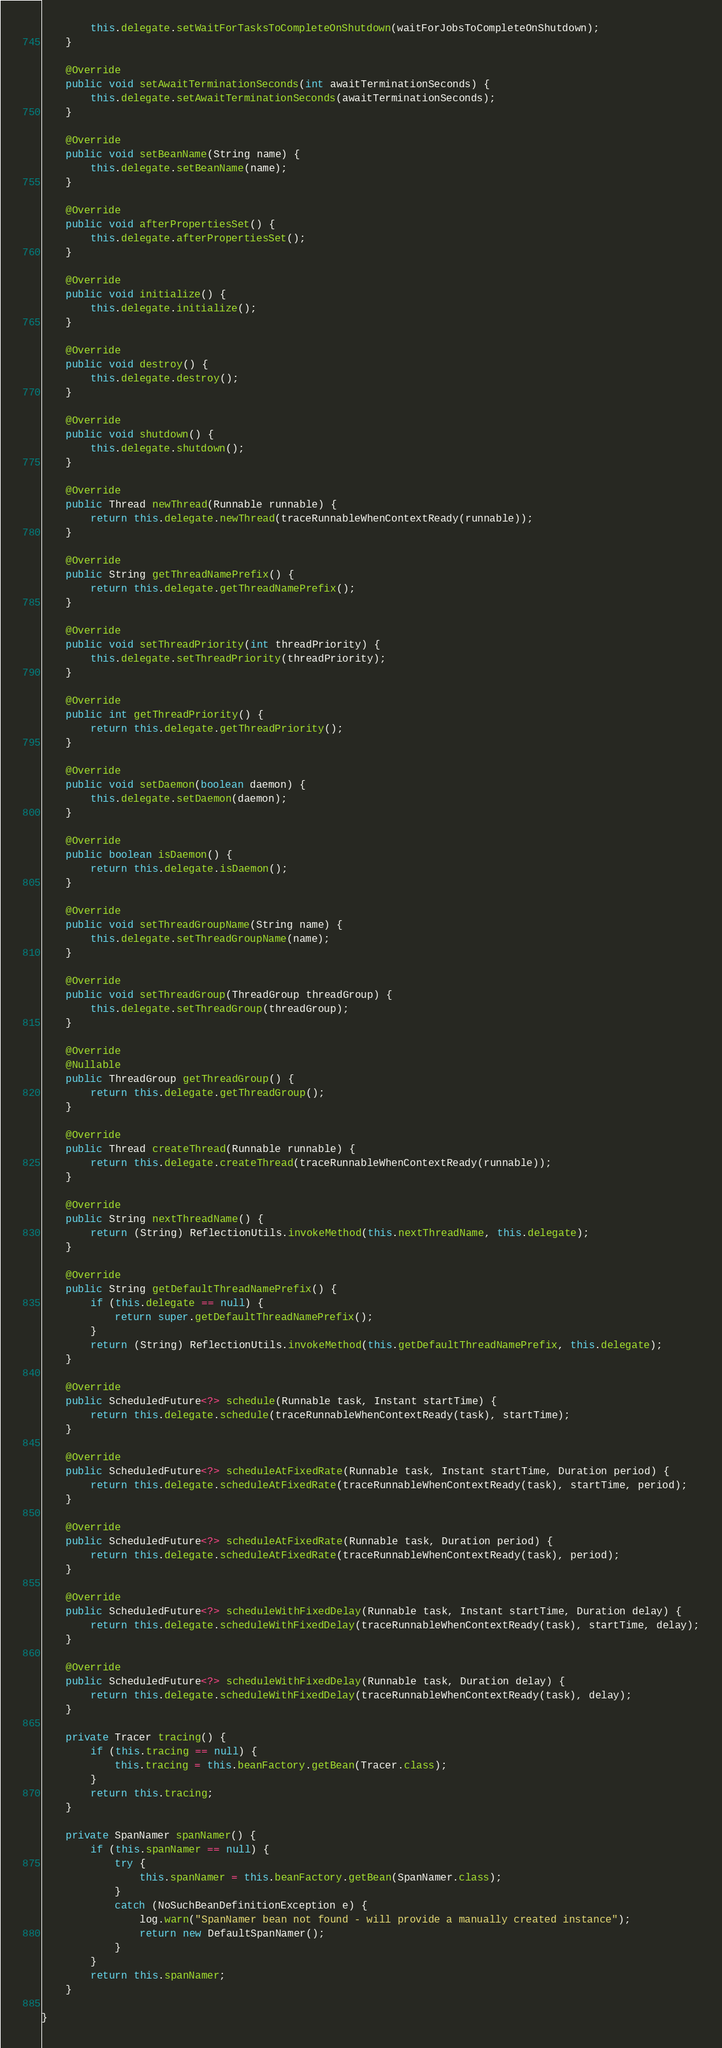Convert code to text. <code><loc_0><loc_0><loc_500><loc_500><_Java_>		this.delegate.setWaitForTasksToCompleteOnShutdown(waitForJobsToCompleteOnShutdown);
	}

	@Override
	public void setAwaitTerminationSeconds(int awaitTerminationSeconds) {
		this.delegate.setAwaitTerminationSeconds(awaitTerminationSeconds);
	}

	@Override
	public void setBeanName(String name) {
		this.delegate.setBeanName(name);
	}

	@Override
	public void afterPropertiesSet() {
		this.delegate.afterPropertiesSet();
	}

	@Override
	public void initialize() {
		this.delegate.initialize();
	}

	@Override
	public void destroy() {
		this.delegate.destroy();
	}

	@Override
	public void shutdown() {
		this.delegate.shutdown();
	}

	@Override
	public Thread newThread(Runnable runnable) {
		return this.delegate.newThread(traceRunnableWhenContextReady(runnable));
	}

	@Override
	public String getThreadNamePrefix() {
		return this.delegate.getThreadNamePrefix();
	}

	@Override
	public void setThreadPriority(int threadPriority) {
		this.delegate.setThreadPriority(threadPriority);
	}

	@Override
	public int getThreadPriority() {
		return this.delegate.getThreadPriority();
	}

	@Override
	public void setDaemon(boolean daemon) {
		this.delegate.setDaemon(daemon);
	}

	@Override
	public boolean isDaemon() {
		return this.delegate.isDaemon();
	}

	@Override
	public void setThreadGroupName(String name) {
		this.delegate.setThreadGroupName(name);
	}

	@Override
	public void setThreadGroup(ThreadGroup threadGroup) {
		this.delegate.setThreadGroup(threadGroup);
	}

	@Override
	@Nullable
	public ThreadGroup getThreadGroup() {
		return this.delegate.getThreadGroup();
	}

	@Override
	public Thread createThread(Runnable runnable) {
		return this.delegate.createThread(traceRunnableWhenContextReady(runnable));
	}

	@Override
	public String nextThreadName() {
		return (String) ReflectionUtils.invokeMethod(this.nextThreadName, this.delegate);
	}

	@Override
	public String getDefaultThreadNamePrefix() {
		if (this.delegate == null) {
			return super.getDefaultThreadNamePrefix();
		}
		return (String) ReflectionUtils.invokeMethod(this.getDefaultThreadNamePrefix, this.delegate);
	}

	@Override
	public ScheduledFuture<?> schedule(Runnable task, Instant startTime) {
		return this.delegate.schedule(traceRunnableWhenContextReady(task), startTime);
	}

	@Override
	public ScheduledFuture<?> scheduleAtFixedRate(Runnable task, Instant startTime, Duration period) {
		return this.delegate.scheduleAtFixedRate(traceRunnableWhenContextReady(task), startTime, period);
	}

	@Override
	public ScheduledFuture<?> scheduleAtFixedRate(Runnable task, Duration period) {
		return this.delegate.scheduleAtFixedRate(traceRunnableWhenContextReady(task), period);
	}

	@Override
	public ScheduledFuture<?> scheduleWithFixedDelay(Runnable task, Instant startTime, Duration delay) {
		return this.delegate.scheduleWithFixedDelay(traceRunnableWhenContextReady(task), startTime, delay);
	}

	@Override
	public ScheduledFuture<?> scheduleWithFixedDelay(Runnable task, Duration delay) {
		return this.delegate.scheduleWithFixedDelay(traceRunnableWhenContextReady(task), delay);
	}

	private Tracer tracing() {
		if (this.tracing == null) {
			this.tracing = this.beanFactory.getBean(Tracer.class);
		}
		return this.tracing;
	}

	private SpanNamer spanNamer() {
		if (this.spanNamer == null) {
			try {
				this.spanNamer = this.beanFactory.getBean(SpanNamer.class);
			}
			catch (NoSuchBeanDefinitionException e) {
				log.warn("SpanNamer bean not found - will provide a manually created instance");
				return new DefaultSpanNamer();
			}
		}
		return this.spanNamer;
	}

}
</code> 